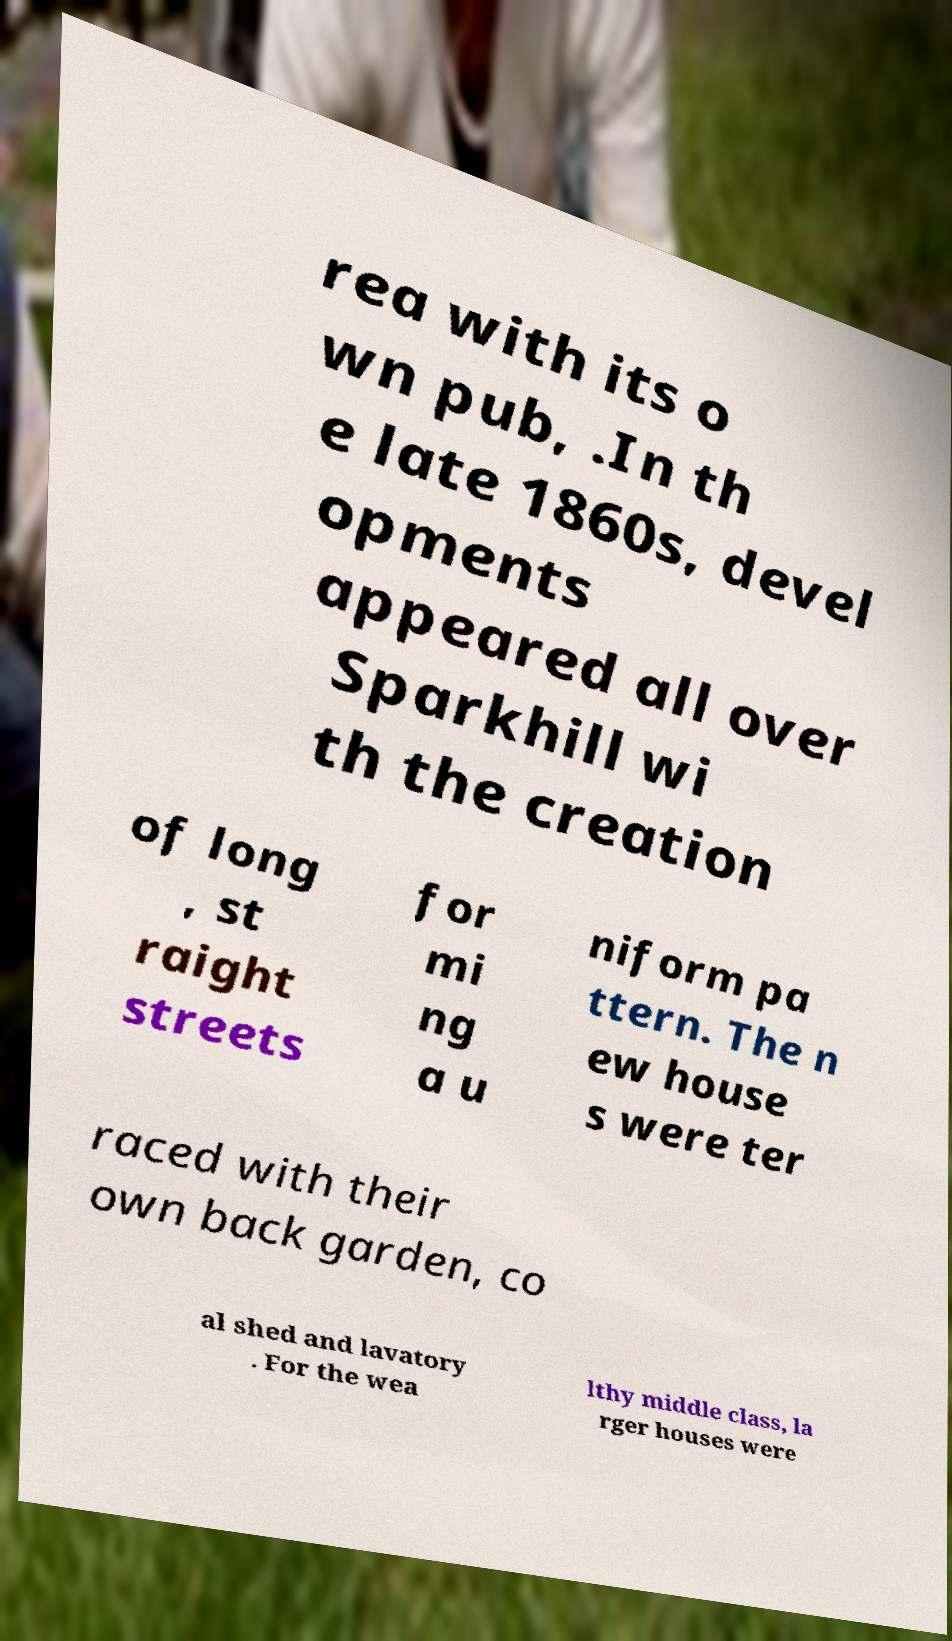There's text embedded in this image that I need extracted. Can you transcribe it verbatim? rea with its o wn pub, .In th e late 1860s, devel opments appeared all over Sparkhill wi th the creation of long , st raight streets for mi ng a u niform pa ttern. The n ew house s were ter raced with their own back garden, co al shed and lavatory . For the wea lthy middle class, la rger houses were 